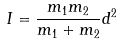Convert formula to latex. <formula><loc_0><loc_0><loc_500><loc_500>I = \frac { m _ { 1 } m _ { 2 } } { m _ { 1 } + m _ { 2 } } d ^ { 2 }</formula> 